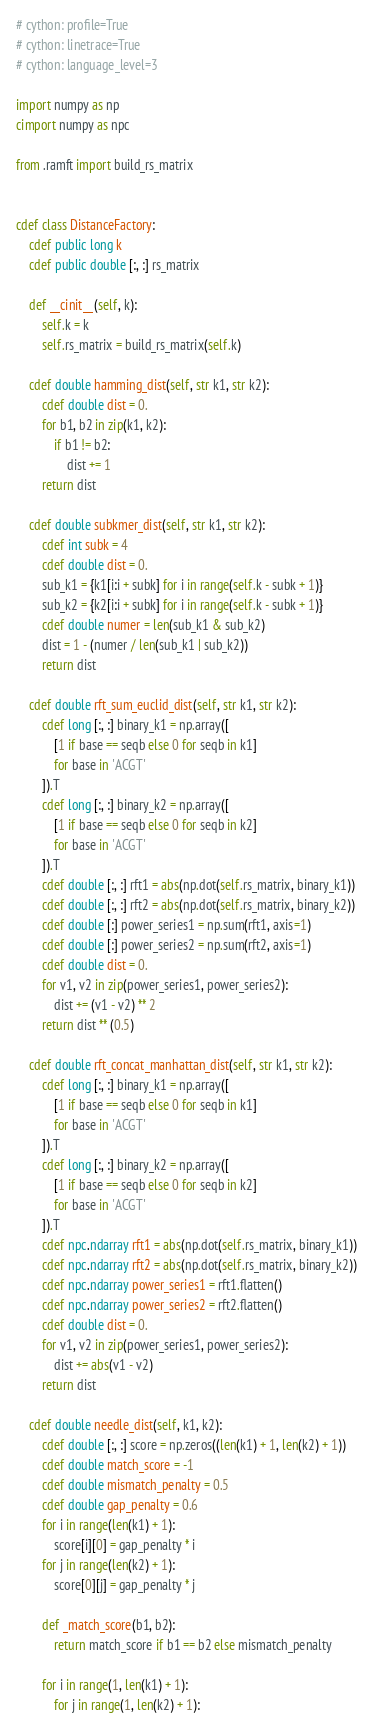Convert code to text. <code><loc_0><loc_0><loc_500><loc_500><_Cython_># cython: profile=True
# cython: linetrace=True
# cython: language_level=3

import numpy as np
cimport numpy as npc

from .ramft import build_rs_matrix


cdef class DistanceFactory:
    cdef public long k
    cdef public double [:, :] rs_matrix

    def __cinit__(self, k):
        self.k = k
        self.rs_matrix = build_rs_matrix(self.k)

    cdef double hamming_dist(self, str k1, str k2):
        cdef double dist = 0.
        for b1, b2 in zip(k1, k2):
            if b1 != b2:
                dist += 1
        return dist

    cdef double subkmer_dist(self, str k1, str k2):
        cdef int subk = 4
        cdef double dist = 0.
        sub_k1 = {k1[i:i + subk] for i in range(self.k - subk + 1)}
        sub_k2 = {k2[i:i + subk] for i in range(self.k - subk + 1)}
        cdef double numer = len(sub_k1 & sub_k2)
        dist = 1 - (numer / len(sub_k1 | sub_k2))
        return dist

    cdef double rft_sum_euclid_dist(self, str k1, str k2):
        cdef long [:, :] binary_k1 = np.array([
            [1 if base == seqb else 0 for seqb in k1]
            for base in 'ACGT'
        ]).T
        cdef long [:, :] binary_k2 = np.array([
            [1 if base == seqb else 0 for seqb in k2]
            for base in 'ACGT'
        ]).T
        cdef double [:, :] rft1 = abs(np.dot(self.rs_matrix, binary_k1))
        cdef double [:, :] rft2 = abs(np.dot(self.rs_matrix, binary_k2))
        cdef double [:] power_series1 = np.sum(rft1, axis=1)
        cdef double [:] power_series2 = np.sum(rft2, axis=1)
        cdef double dist = 0.
        for v1, v2 in zip(power_series1, power_series2):
            dist += (v1 - v2) ** 2
        return dist ** (0.5)

    cdef double rft_concat_manhattan_dist(self, str k1, str k2):
        cdef long [:, :] binary_k1 = np.array([
            [1 if base == seqb else 0 for seqb in k1]
            for base in 'ACGT'
        ]).T
        cdef long [:, :] binary_k2 = np.array([
            [1 if base == seqb else 0 for seqb in k2]
            for base in 'ACGT'
        ]).T
        cdef npc.ndarray rft1 = abs(np.dot(self.rs_matrix, binary_k1))
        cdef npc.ndarray rft2 = abs(np.dot(self.rs_matrix, binary_k2))
        cdef npc.ndarray power_series1 = rft1.flatten()
        cdef npc.ndarray power_series2 = rft2.flatten()
        cdef double dist = 0.
        for v1, v2 in zip(power_series1, power_series2):
            dist += abs(v1 - v2)
        return dist

    cdef double needle_dist(self, k1, k2):
        cdef double [:, :] score = np.zeros((len(k1) + 1, len(k2) + 1))
        cdef double match_score = -1
        cdef double mismatch_penalty = 0.5
        cdef double gap_penalty = 0.6
        for i in range(len(k1) + 1):
            score[i][0] = gap_penalty * i
        for j in range(len(k2) + 1):
            score[0][j] = gap_penalty * j

        def _match_score(b1, b2):
            return match_score if b1 == b2 else mismatch_penalty

        for i in range(1, len(k1) + 1):
            for j in range(1, len(k2) + 1):</code> 